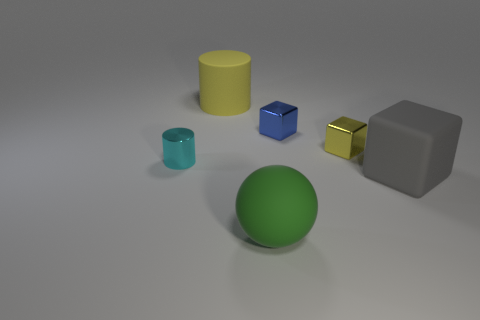Add 2 small shiny cubes. How many objects exist? 8 Subtract all cylinders. How many objects are left? 4 Subtract 1 blue blocks. How many objects are left? 5 Subtract all tiny yellow metallic things. Subtract all gray matte things. How many objects are left? 4 Add 5 small cyan shiny things. How many small cyan shiny things are left? 6 Add 5 purple cylinders. How many purple cylinders exist? 5 